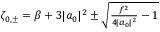<formula> <loc_0><loc_0><loc_500><loc_500>\begin{array} { r } { \zeta _ { 0 , \pm } = \beta + 3 | a _ { 0 } | ^ { 2 } \pm \sqrt { \frac { f ^ { 2 } } { 4 | a _ { 0 } | ^ { 2 } } - 1 } } \end{array}</formula> 